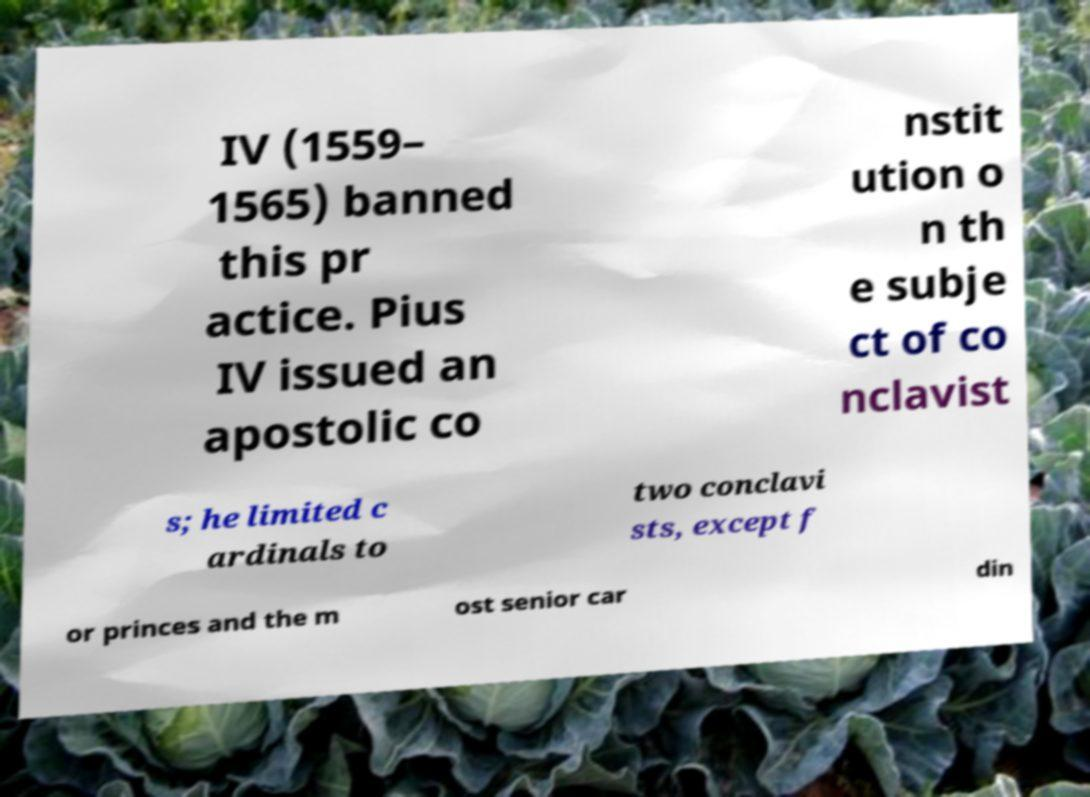I need the written content from this picture converted into text. Can you do that? IV (1559– 1565) banned this pr actice. Pius IV issued an apostolic co nstit ution o n th e subje ct of co nclavist s; he limited c ardinals to two conclavi sts, except f or princes and the m ost senior car din 